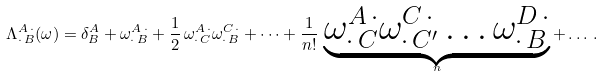<formula> <loc_0><loc_0><loc_500><loc_500>\Lambda ^ { A \, \cdot } _ { \cdot \, B } ( \omega ) = \delta ^ { A } _ { B } + \omega ^ { A \, \cdot } _ { \cdot \, B } + \frac { 1 } { 2 } \, \omega ^ { A \, \cdot } _ { \cdot \, C } \omega ^ { C \, \cdot } _ { \cdot \, B } + \dots + \frac { 1 } { n ! } \, \underbrace { \omega ^ { A \, \cdot } _ { \cdot \, C } \omega ^ { C \, \cdot } _ { \cdot \, C ^ { \prime } } \dots \omega ^ { D \, \cdot } _ { \cdot \, B } } _ { n } + \dots \, .</formula> 